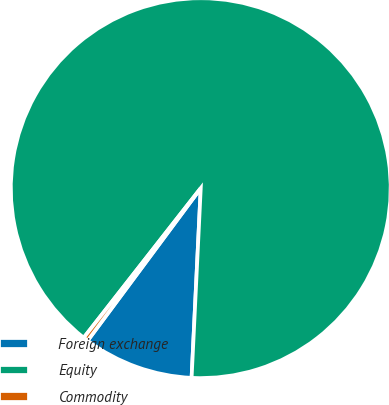Convert chart. <chart><loc_0><loc_0><loc_500><loc_500><pie_chart><fcel>Foreign exchange<fcel>Equity<fcel>Commodity<nl><fcel>9.39%<fcel>90.21%<fcel>0.41%<nl></chart> 